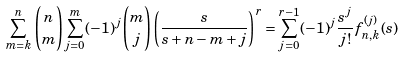<formula> <loc_0><loc_0><loc_500><loc_500>\sum _ { m = k } ^ { n } \binom { n } { m } \sum _ { j = 0 } ^ { m } ( - 1 ) ^ { j } \binom { m } { j } \left ( \frac { s } { s + n - m + j } \right ) ^ { r } & = \sum _ { j = 0 } ^ { r - 1 } ( - 1 ) ^ { j } \frac { s ^ { j } } { j ! } f ^ { ( j ) } _ { n , k } ( s )</formula> 